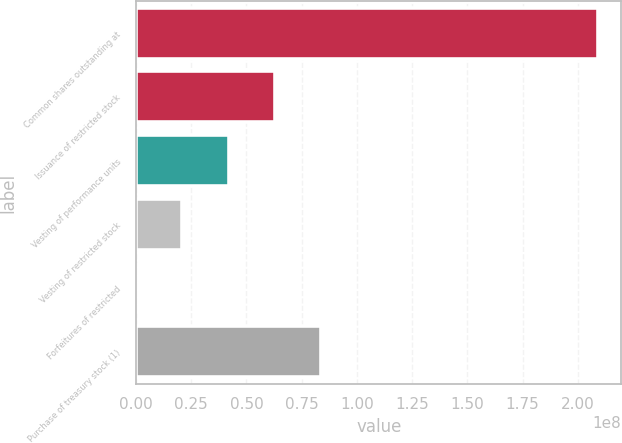Convert chart to OTSL. <chart><loc_0><loc_0><loc_500><loc_500><bar_chart><fcel>Common shares outstanding at<fcel>Issuance of restricted stock<fcel>Vesting of performance units<fcel>Vesting of restricted stock<fcel>Forfeitures of restricted<fcel>Purchase of treasury stock (1)<nl><fcel>2.09333e+08<fcel>6.28024e+07<fcel>4.18695e+07<fcel>2.09366e+07<fcel>3730<fcel>8.37353e+07<nl></chart> 